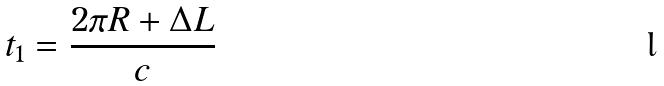Convert formula to latex. <formula><loc_0><loc_0><loc_500><loc_500>t _ { 1 } = \frac { 2 \pi R + \Delta L } { c }</formula> 